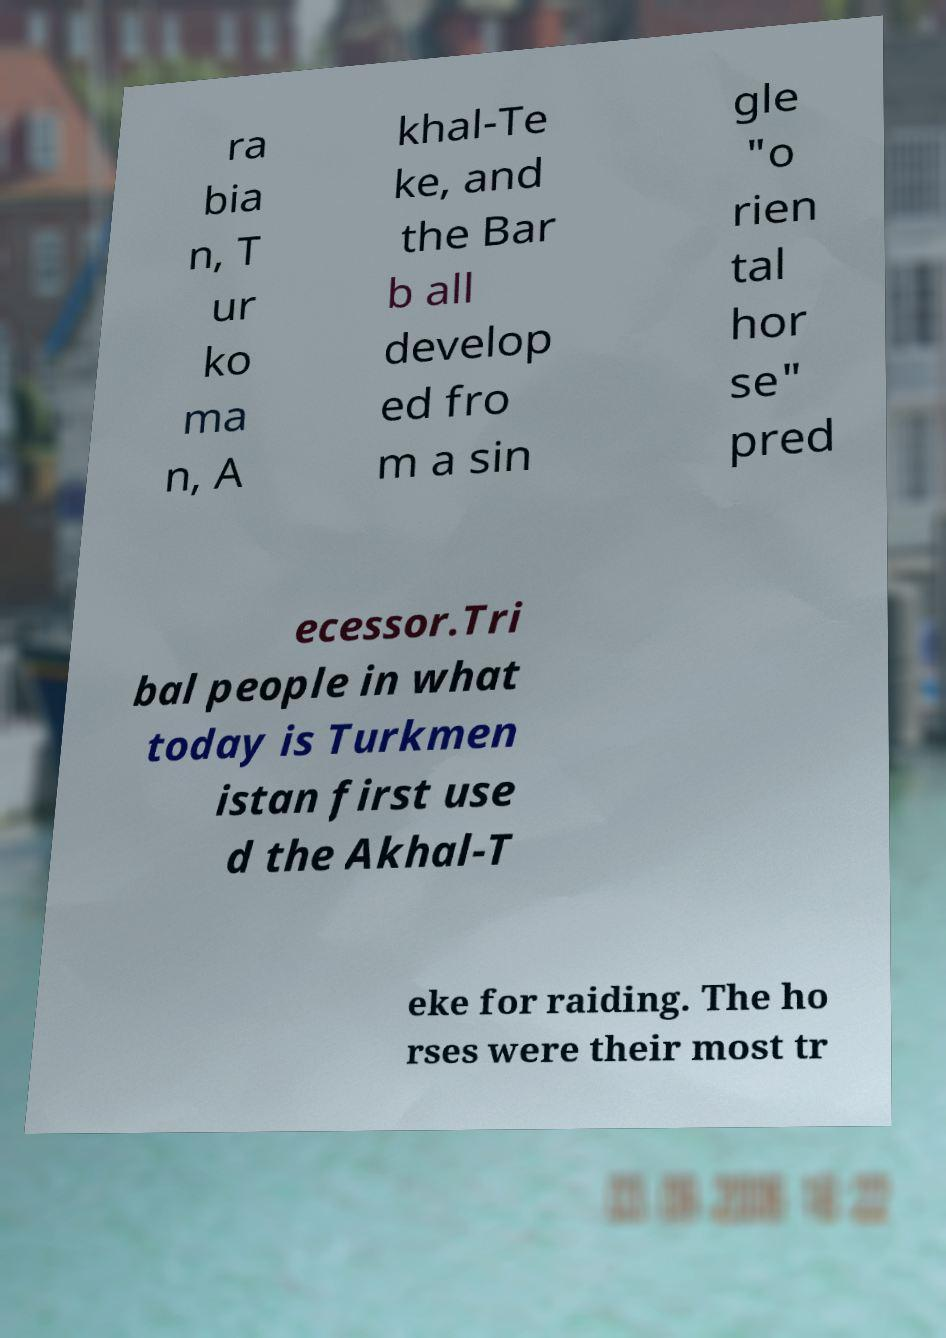There's text embedded in this image that I need extracted. Can you transcribe it verbatim? ra bia n, T ur ko ma n, A khal-Te ke, and the Bar b all develop ed fro m a sin gle "o rien tal hor se" pred ecessor.Tri bal people in what today is Turkmen istan first use d the Akhal-T eke for raiding. The ho rses were their most tr 